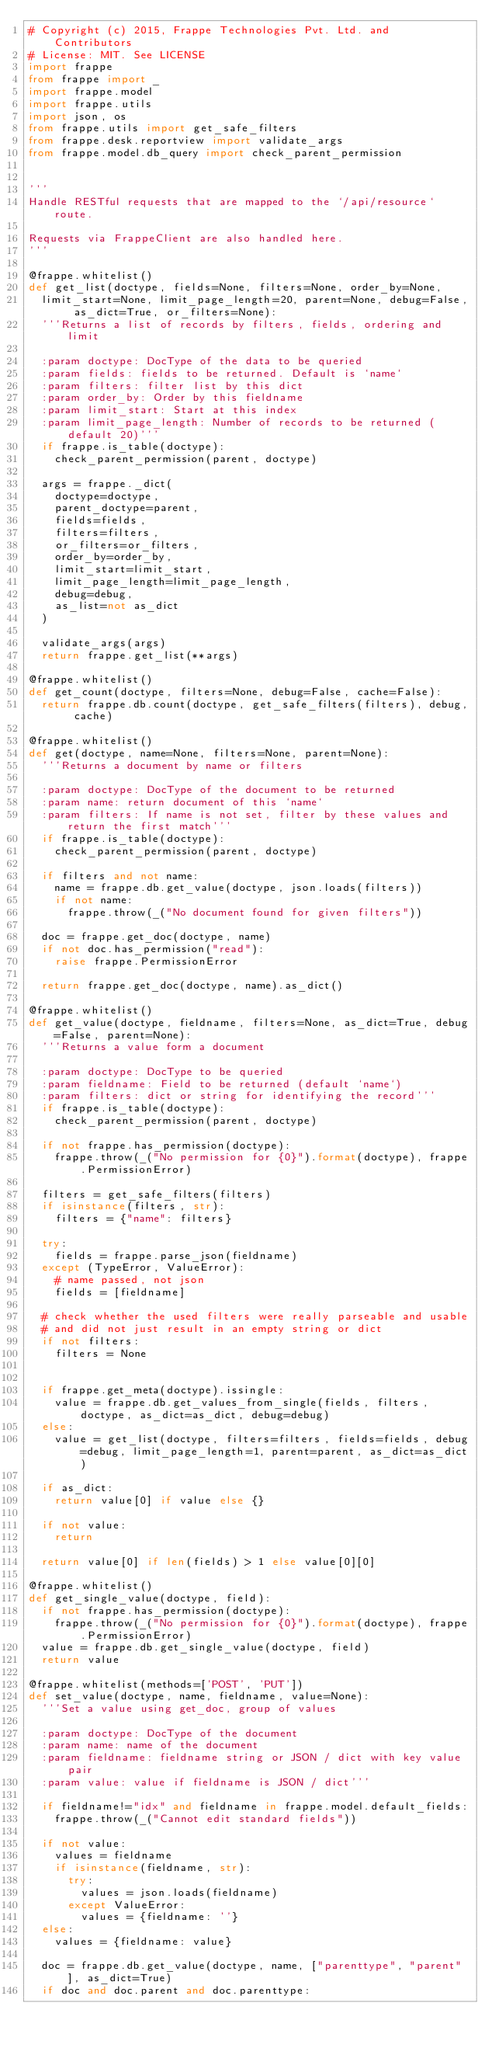<code> <loc_0><loc_0><loc_500><loc_500><_Python_># Copyright (c) 2015, Frappe Technologies Pvt. Ltd. and Contributors
# License: MIT. See LICENSE
import frappe
from frappe import _
import frappe.model
import frappe.utils
import json, os
from frappe.utils import get_safe_filters
from frappe.desk.reportview import validate_args
from frappe.model.db_query import check_parent_permission


'''
Handle RESTful requests that are mapped to the `/api/resource` route.

Requests via FrappeClient are also handled here.
'''

@frappe.whitelist()
def get_list(doctype, fields=None, filters=None, order_by=None,
	limit_start=None, limit_page_length=20, parent=None, debug=False, as_dict=True, or_filters=None):
	'''Returns a list of records by filters, fields, ordering and limit

	:param doctype: DocType of the data to be queried
	:param fields: fields to be returned. Default is `name`
	:param filters: filter list by this dict
	:param order_by: Order by this fieldname
	:param limit_start: Start at this index
	:param limit_page_length: Number of records to be returned (default 20)'''
	if frappe.is_table(doctype):
		check_parent_permission(parent, doctype)

	args = frappe._dict(
		doctype=doctype,
		parent_doctype=parent,
		fields=fields,
		filters=filters,
		or_filters=or_filters,
		order_by=order_by,
		limit_start=limit_start,
		limit_page_length=limit_page_length,
		debug=debug,
		as_list=not as_dict
	)

	validate_args(args)
	return frappe.get_list(**args)

@frappe.whitelist()
def get_count(doctype, filters=None, debug=False, cache=False):
	return frappe.db.count(doctype, get_safe_filters(filters), debug, cache)

@frappe.whitelist()
def get(doctype, name=None, filters=None, parent=None):
	'''Returns a document by name or filters

	:param doctype: DocType of the document to be returned
	:param name: return document of this `name`
	:param filters: If name is not set, filter by these values and return the first match'''
	if frappe.is_table(doctype):
		check_parent_permission(parent, doctype)

	if filters and not name:
		name = frappe.db.get_value(doctype, json.loads(filters))
		if not name:
			frappe.throw(_("No document found for given filters"))

	doc = frappe.get_doc(doctype, name)
	if not doc.has_permission("read"):
		raise frappe.PermissionError

	return frappe.get_doc(doctype, name).as_dict()

@frappe.whitelist()
def get_value(doctype, fieldname, filters=None, as_dict=True, debug=False, parent=None):
	'''Returns a value form a document

	:param doctype: DocType to be queried
	:param fieldname: Field to be returned (default `name`)
	:param filters: dict or string for identifying the record'''
	if frappe.is_table(doctype):
		check_parent_permission(parent, doctype)

	if not frappe.has_permission(doctype):
		frappe.throw(_("No permission for {0}").format(doctype), frappe.PermissionError)

	filters = get_safe_filters(filters)
	if isinstance(filters, str):
		filters = {"name": filters}

	try:
		fields = frappe.parse_json(fieldname)
	except (TypeError, ValueError):
		# name passed, not json
		fields = [fieldname]

	# check whether the used filters were really parseable and usable
	# and did not just result in an empty string or dict
	if not filters:
		filters = None


	if frappe.get_meta(doctype).issingle:
		value = frappe.db.get_values_from_single(fields, filters, doctype, as_dict=as_dict, debug=debug)
	else:
		value = get_list(doctype, filters=filters, fields=fields, debug=debug, limit_page_length=1, parent=parent, as_dict=as_dict)

	if as_dict:
		return value[0] if value else {}

	if not value:
		return

	return value[0] if len(fields) > 1 else value[0][0]

@frappe.whitelist()
def get_single_value(doctype, field):
	if not frappe.has_permission(doctype):
		frappe.throw(_("No permission for {0}").format(doctype), frappe.PermissionError)
	value = frappe.db.get_single_value(doctype, field)
	return value

@frappe.whitelist(methods=['POST', 'PUT'])
def set_value(doctype, name, fieldname, value=None):
	'''Set a value using get_doc, group of values

	:param doctype: DocType of the document
	:param name: name of the document
	:param fieldname: fieldname string or JSON / dict with key value pair
	:param value: value if fieldname is JSON / dict'''

	if fieldname!="idx" and fieldname in frappe.model.default_fields:
		frappe.throw(_("Cannot edit standard fields"))

	if not value:
		values = fieldname
		if isinstance(fieldname, str):
			try:
				values = json.loads(fieldname)
			except ValueError:
				values = {fieldname: ''}
	else:
		values = {fieldname: value}

	doc = frappe.db.get_value(doctype, name, ["parenttype", "parent"], as_dict=True)
	if doc and doc.parent and doc.parenttype:</code> 